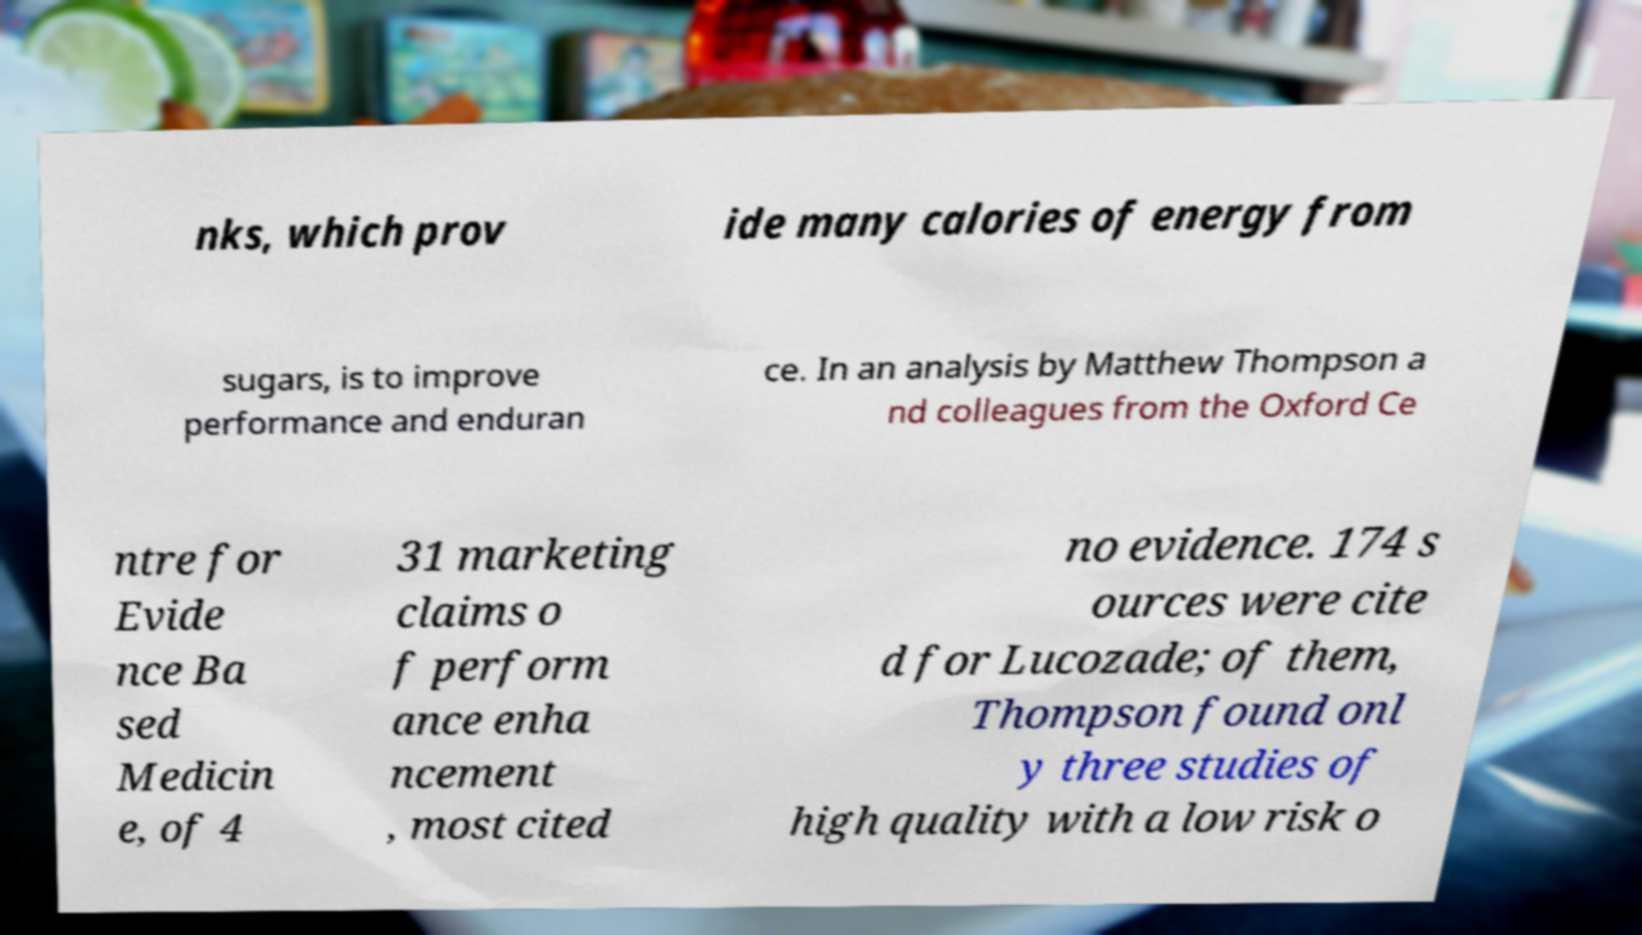I need the written content from this picture converted into text. Can you do that? nks, which prov ide many calories of energy from sugars, is to improve performance and enduran ce. In an analysis by Matthew Thompson a nd colleagues from the Oxford Ce ntre for Evide nce Ba sed Medicin e, of 4 31 marketing claims o f perform ance enha ncement , most cited no evidence. 174 s ources were cite d for Lucozade; of them, Thompson found onl y three studies of high quality with a low risk o 